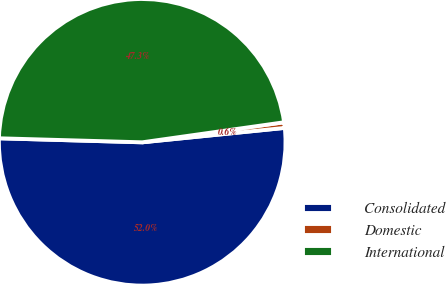<chart> <loc_0><loc_0><loc_500><loc_500><pie_chart><fcel>Consolidated<fcel>Domestic<fcel>International<nl><fcel>52.05%<fcel>0.63%<fcel>47.32%<nl></chart> 